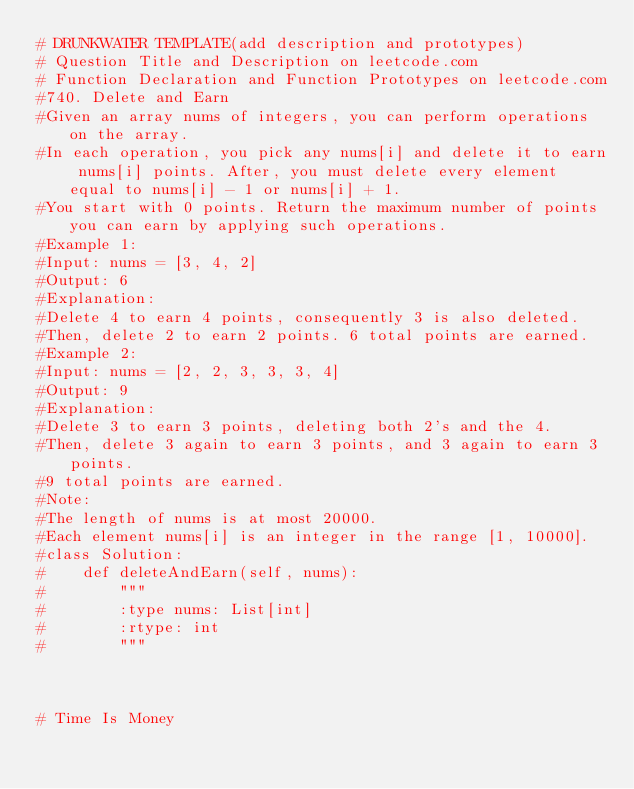<code> <loc_0><loc_0><loc_500><loc_500><_Python_># DRUNKWATER TEMPLATE(add description and prototypes)
# Question Title and Description on leetcode.com
# Function Declaration and Function Prototypes on leetcode.com
#740. Delete and Earn
#Given an array nums of integers, you can perform operations on the array.
#In each operation, you pick any nums[i] and delete it to earn nums[i] points. After, you must delete every element equal to nums[i] - 1 or nums[i] + 1.
#You start with 0 points. Return the maximum number of points you can earn by applying such operations.
#Example 1:
#Input: nums = [3, 4, 2]
#Output: 6
#Explanation: 
#Delete 4 to earn 4 points, consequently 3 is also deleted.
#Then, delete 2 to earn 2 points. 6 total points are earned.
#Example 2:
#Input: nums = [2, 2, 3, 3, 3, 4]
#Output: 9
#Explanation: 
#Delete 3 to earn 3 points, deleting both 2's and the 4.
#Then, delete 3 again to earn 3 points, and 3 again to earn 3 points.
#9 total points are earned.
#Note:
#The length of nums is at most 20000.
#Each element nums[i] is an integer in the range [1, 10000].
#class Solution:
#    def deleteAndEarn(self, nums):
#        """
#        :type nums: List[int]
#        :rtype: int
#        """



# Time Is Money</code> 